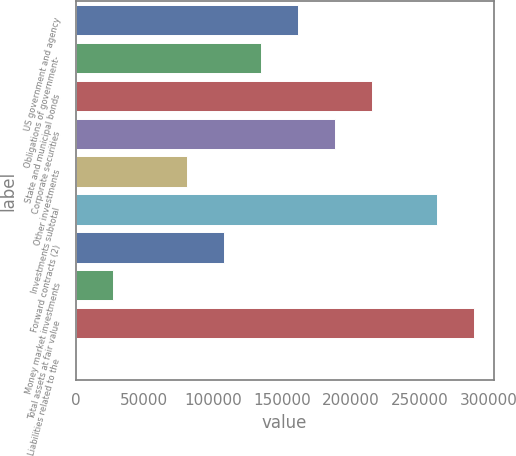<chart> <loc_0><loc_0><loc_500><loc_500><bar_chart><fcel>US government and agency<fcel>Obligations of government-<fcel>State and municipal bonds<fcel>Corporate securities<fcel>Other investments<fcel>Investments subtotal<fcel>Forward contracts (2)<fcel>Money market investments<fcel>Total assets at fair value<fcel>Liabilities related to the<nl><fcel>161241<fcel>134368<fcel>214987<fcel>188114<fcel>80621.6<fcel>262149<fcel>107495<fcel>26875.5<fcel>289022<fcel>2.47<nl></chart> 